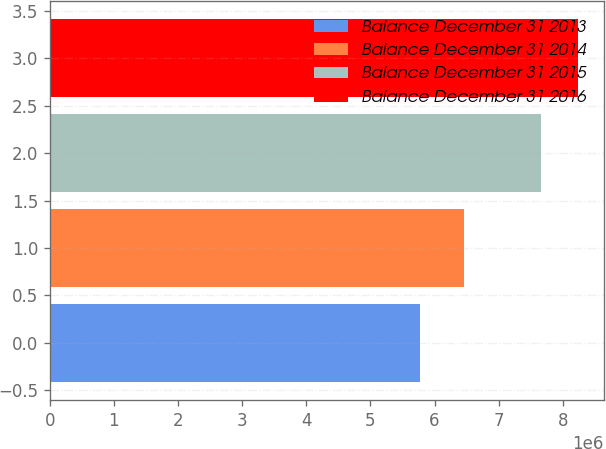Convert chart to OTSL. <chart><loc_0><loc_0><loc_500><loc_500><bar_chart><fcel>Balance December 31 2013<fcel>Balance December 31 2014<fcel>Balance December 31 2015<fcel>Balance December 31 2016<nl><fcel>5.76788e+06<fcel>6.46499e+06<fcel>7.66643e+06<fcel>8.22859e+06<nl></chart> 